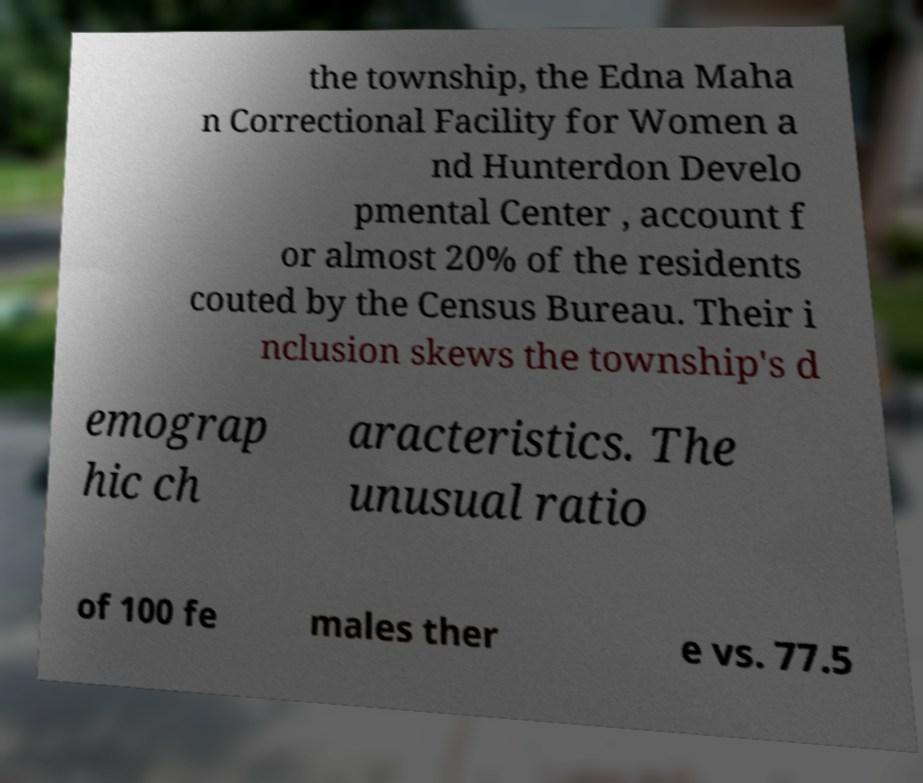What messages or text are displayed in this image? I need them in a readable, typed format. the township, the Edna Maha n Correctional Facility for Women a nd Hunterdon Develo pmental Center , account f or almost 20% of the residents couted by the Census Bureau. Their i nclusion skews the township's d emograp hic ch aracteristics. The unusual ratio of 100 fe males ther e vs. 77.5 